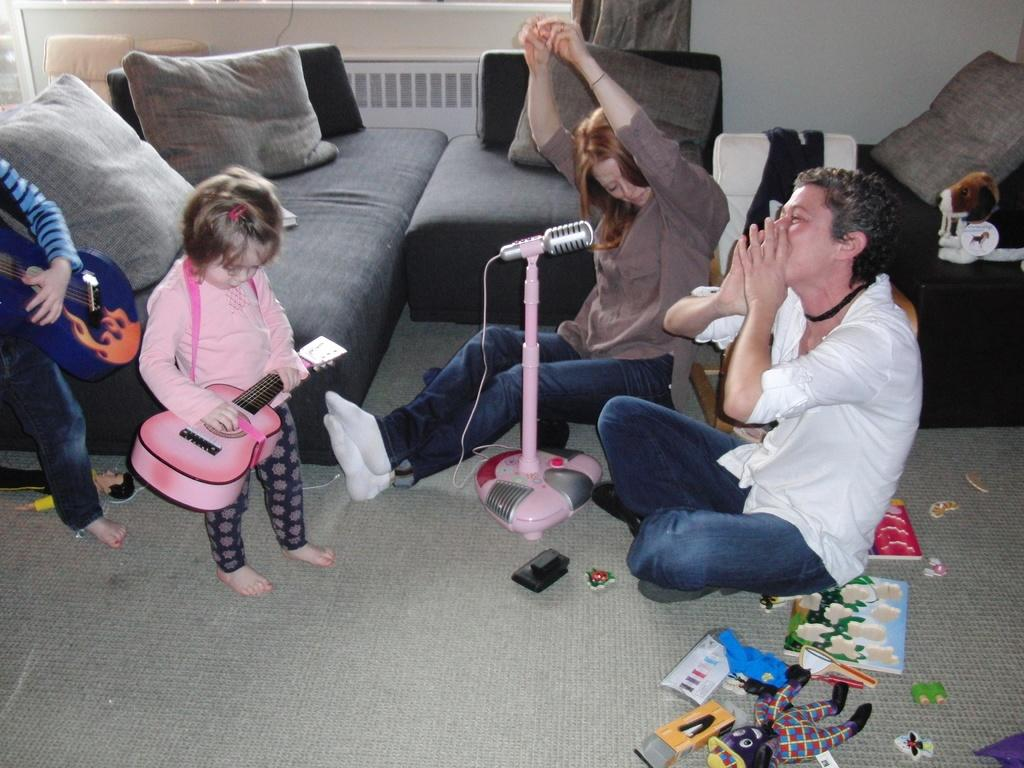How many children are in the room? There are two children in the room. What are the children doing in the image? The children are playing guitar. How many people are sitting on the floor in the image? There are two people sitting on the floor. What object is present in front of the children and people? A microphone is present in front of the children and people. Can you tell me how many cacti are in the room? There are no cacti present in the image. 